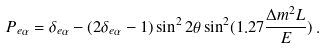<formula> <loc_0><loc_0><loc_500><loc_500>P _ { e \alpha } = \delta _ { e \alpha } - ( 2 \delta _ { e \alpha } - 1 ) \sin ^ { 2 } 2 \theta \sin ^ { 2 } ( 1 . 2 7 \frac { \Delta m ^ { 2 } L } { E } ) \, .</formula> 